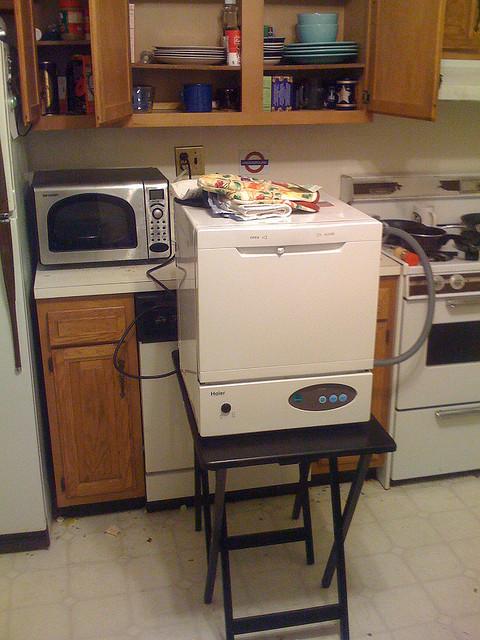Where is the microwave?
Write a very short answer. Counter. What color are the cups in the cabinet?
Keep it brief. Blue. What is on the table?
Answer briefly. Dishwasher. What is odd about this picture?
Be succinct. None. What color is the microwave?
Concise answer only. Silver. 